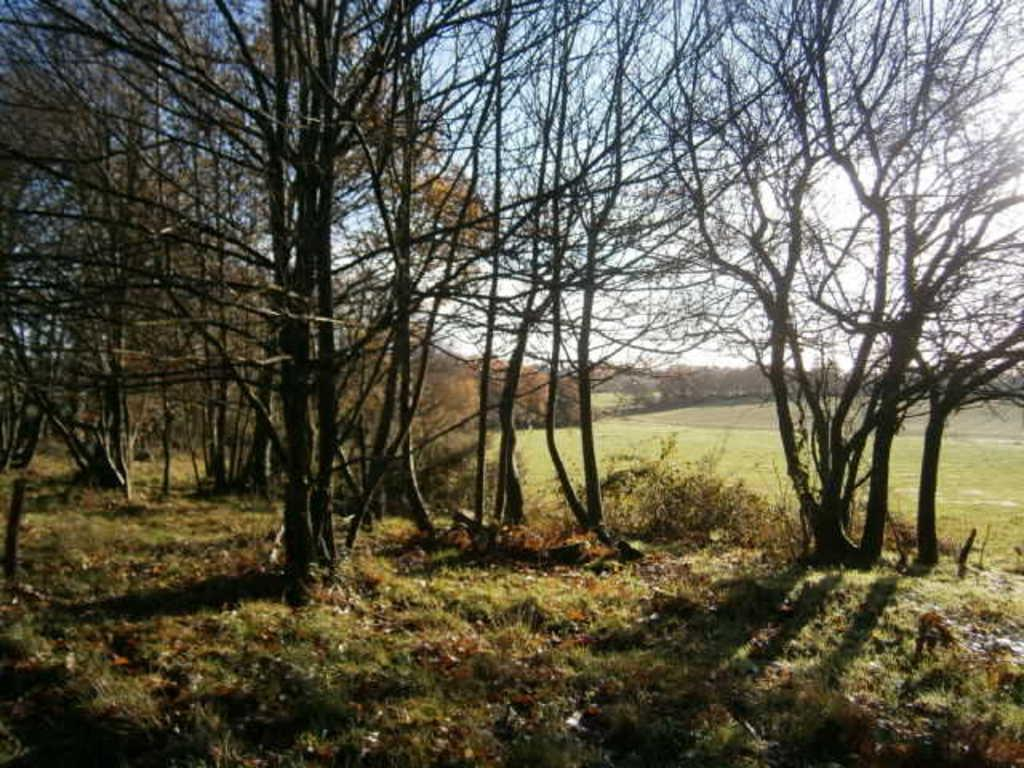What type of vegetation can be seen in the image? There are trees, plants, and grass in the image. What part of the natural environment is visible in the image? The sky is visible in the image. What type of coach can be seen in the image? There is no coach present in the image; it features natural elements such as trees, plants, grass, and the sky. 